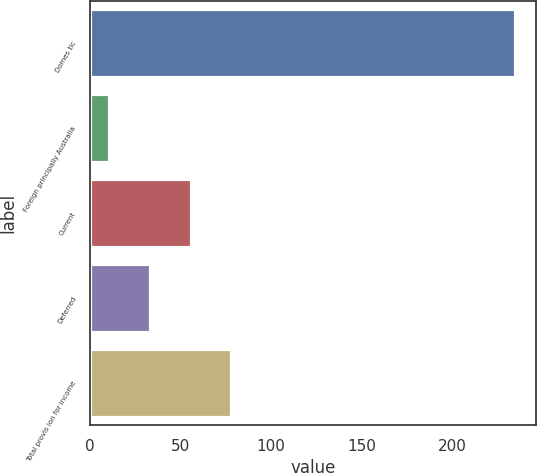<chart> <loc_0><loc_0><loc_500><loc_500><bar_chart><fcel>Domes tic<fcel>Foreign principally Australia<fcel>Current<fcel>Deferred<fcel>Total provis ion for income<nl><fcel>234.7<fcel>10.6<fcel>55.42<fcel>33.01<fcel>77.83<nl></chart> 